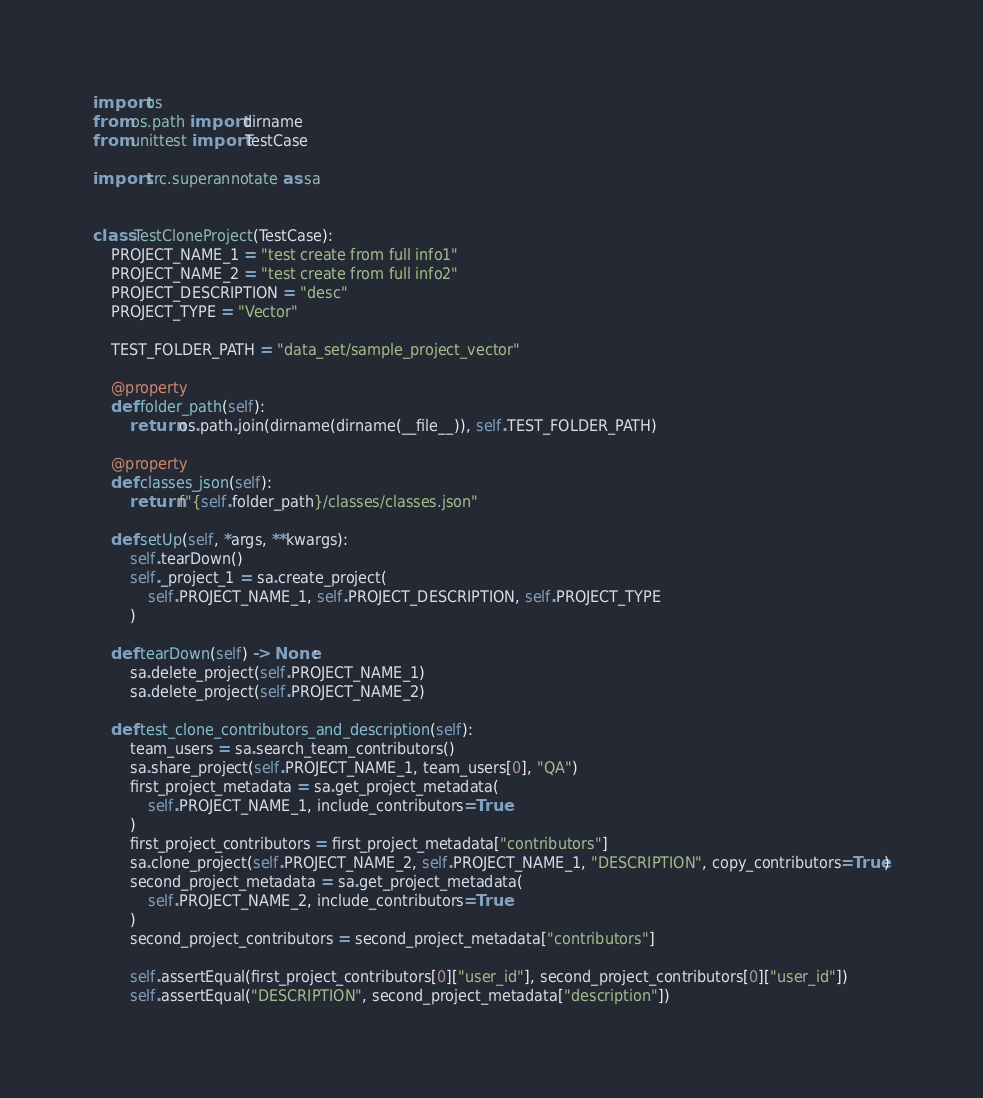Convert code to text. <code><loc_0><loc_0><loc_500><loc_500><_Python_>import os
from os.path import dirname
from unittest import TestCase

import src.superannotate as sa


class TestCloneProject(TestCase):
    PROJECT_NAME_1 = "test create from full info1"
    PROJECT_NAME_2 = "test create from full info2"
    PROJECT_DESCRIPTION = "desc"
    PROJECT_TYPE = "Vector"

    TEST_FOLDER_PATH = "data_set/sample_project_vector"

    @property
    def folder_path(self):
        return os.path.join(dirname(dirname(__file__)), self.TEST_FOLDER_PATH)

    @property
    def classes_json(self):
        return f"{self.folder_path}/classes/classes.json"

    def setUp(self, *args, **kwargs):
        self.tearDown()
        self._project_1 = sa.create_project(
            self.PROJECT_NAME_1, self.PROJECT_DESCRIPTION, self.PROJECT_TYPE
        )

    def tearDown(self) -> None:
        sa.delete_project(self.PROJECT_NAME_1)
        sa.delete_project(self.PROJECT_NAME_2)

    def test_clone_contributors_and_description(self):
        team_users = sa.search_team_contributors()
        sa.share_project(self.PROJECT_NAME_1, team_users[0], "QA")
        first_project_metadata = sa.get_project_metadata(
            self.PROJECT_NAME_1, include_contributors=True
        )
        first_project_contributors = first_project_metadata["contributors"]
        sa.clone_project(self.PROJECT_NAME_2, self.PROJECT_NAME_1, "DESCRIPTION", copy_contributors=True)
        second_project_metadata = sa.get_project_metadata(
            self.PROJECT_NAME_2, include_contributors=True
        )
        second_project_contributors = second_project_metadata["contributors"]

        self.assertEqual(first_project_contributors[0]["user_id"], second_project_contributors[0]["user_id"])
        self.assertEqual("DESCRIPTION", second_project_metadata["description"])</code> 